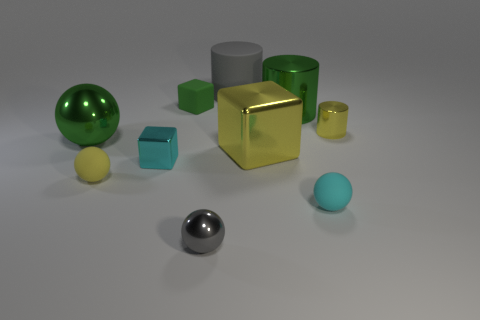Subtract all cylinders. How many objects are left? 7 Subtract 0 purple cylinders. How many objects are left? 10 Subtract all large yellow matte cylinders. Subtract all rubber blocks. How many objects are left? 9 Add 6 green cylinders. How many green cylinders are left? 7 Add 5 large cylinders. How many large cylinders exist? 7 